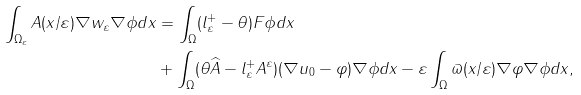<formula> <loc_0><loc_0><loc_500><loc_500>\int _ { \Omega _ { \varepsilon } } A ( x / \varepsilon ) \nabla w _ { \varepsilon } \nabla \phi d x & = \int _ { \Omega } ( l _ { \varepsilon } ^ { + } - \theta ) F \phi d x \\ & + \int _ { \Omega } ( \theta \widehat { A } - l _ { \varepsilon } ^ { + } A ^ { \varepsilon } ) ( \nabla u _ { 0 } - \varphi ) \nabla \phi d x - \varepsilon \int _ { \Omega } \varpi ( x / \varepsilon ) \nabla \varphi \nabla \phi d x ,</formula> 